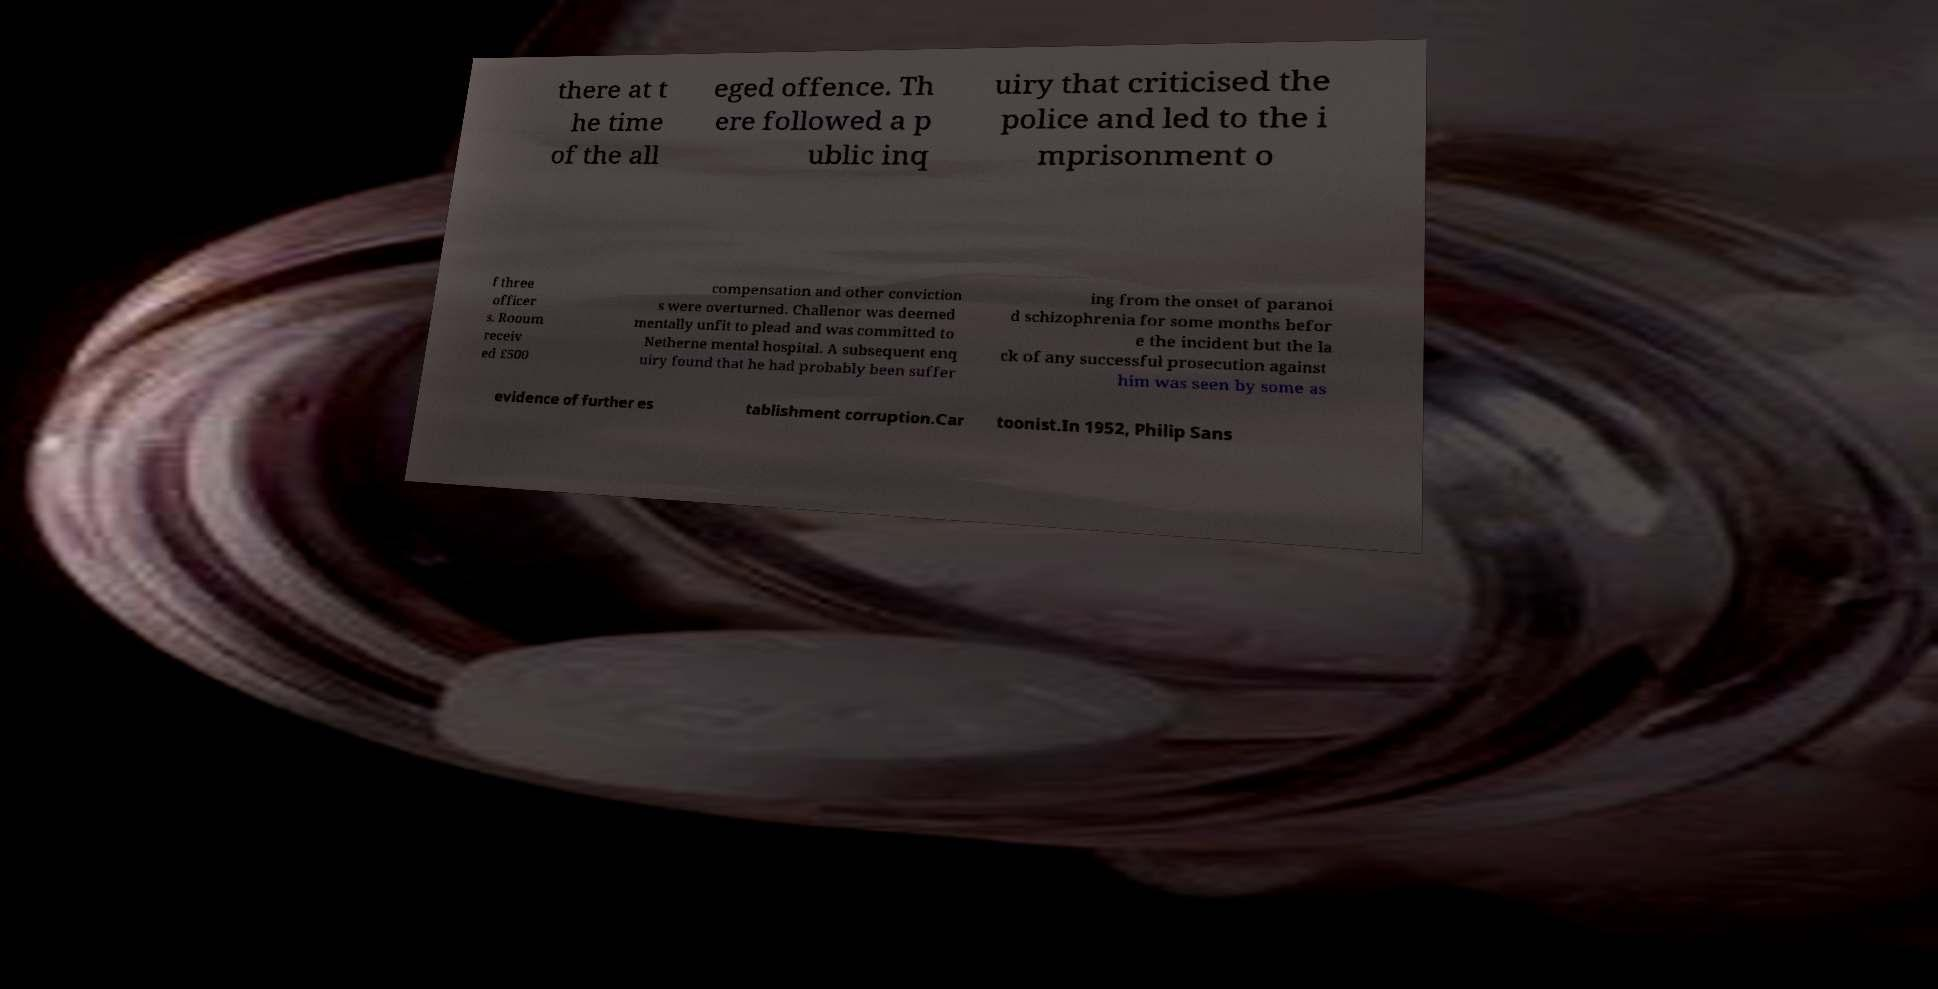I need the written content from this picture converted into text. Can you do that? there at t he time of the all eged offence. Th ere followed a p ublic inq uiry that criticised the police and led to the i mprisonment o f three officer s. Rooum receiv ed £500 compensation and other conviction s were overturned. Challenor was deemed mentally unfit to plead and was committed to Netherne mental hospital. A subsequent enq uiry found that he had probably been suffer ing from the onset of paranoi d schizophrenia for some months befor e the incident but the la ck of any successful prosecution against him was seen by some as evidence of further es tablishment corruption.Car toonist.In 1952, Philip Sans 